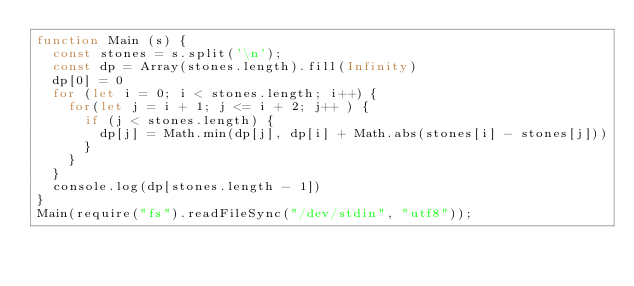<code> <loc_0><loc_0><loc_500><loc_500><_JavaScript_>function Main (s) {
  const stones = s.split('\n');
  const dp = Array(stones.length).fill(Infinity)
  dp[0] = 0
  for (let i = 0; i < stones.length; i++) {
    for(let j = i + 1; j <= i + 2; j++ ) {
      if (j < stones.length) {
        dp[j] = Math.min(dp[j], dp[i] + Math.abs(stones[i] - stones[j]))
      }
    }
  }
  console.log(dp[stones.length - 1])
}
Main(require("fs").readFileSync("/dev/stdin", "utf8"));</code> 